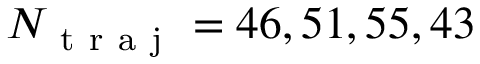<formula> <loc_0><loc_0><loc_500><loc_500>N _ { t r a j } = 4 6 , 5 1 , 5 5 , 4 3</formula> 